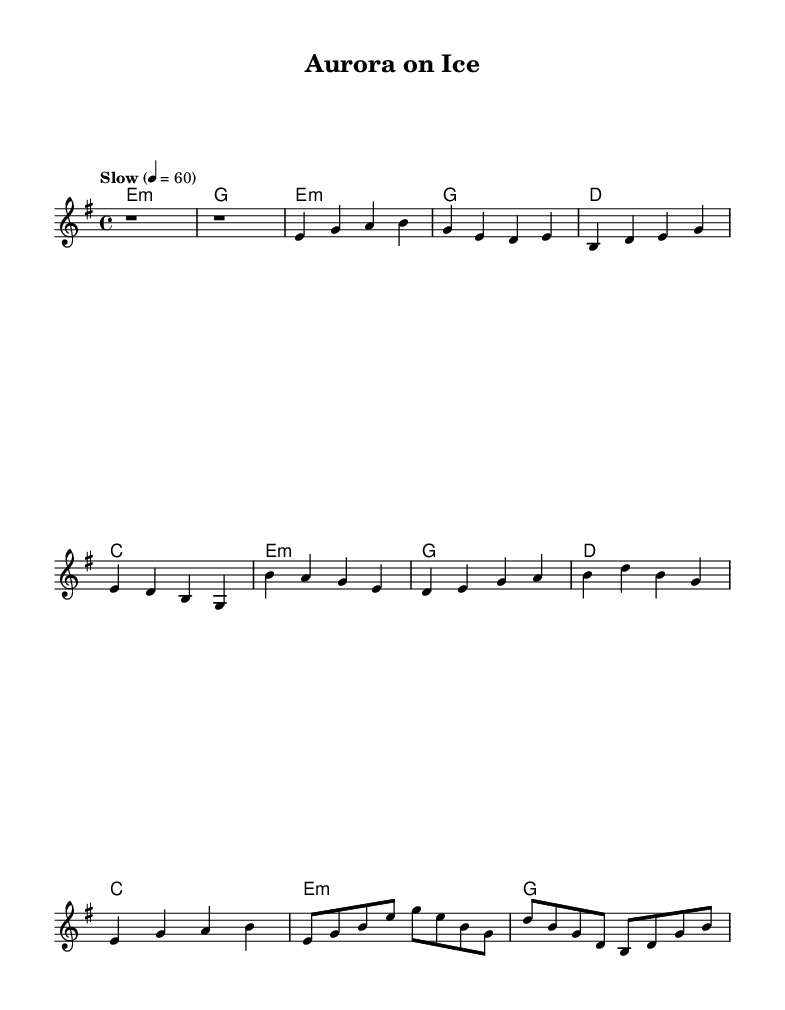What is the key signature of this music? The key signature is E minor, which has one sharp (F#).
Answer: E minor What is the time signature of this music? The time signature is 4/4, indicating four beats per measure.
Answer: 4/4 What is the tempo marking of the piece? The tempo marking is "Slow" with a metronome indication of 60 beats per minute.
Answer: Slow How many measures are in the intro? The intro contains two measures, as indicated by the two rests at the beginning.
Answer: 2 Which chord is used for the chorus? The chorus features the D chord prominently, as indicated in the harmonies section.
Answer: D What is the chord progression in the verse? The chord progression in the verse is E minor, G, D, C, based on the sequential harmonies shown.
Answer: E minor, G, D, C How does the guitar solo's structure compare to the verse? The guitar solo has a similar structure to the verse, both sections start with an E minor chord and have a distinct melodic line with different notes.
Answer: Similar structure 